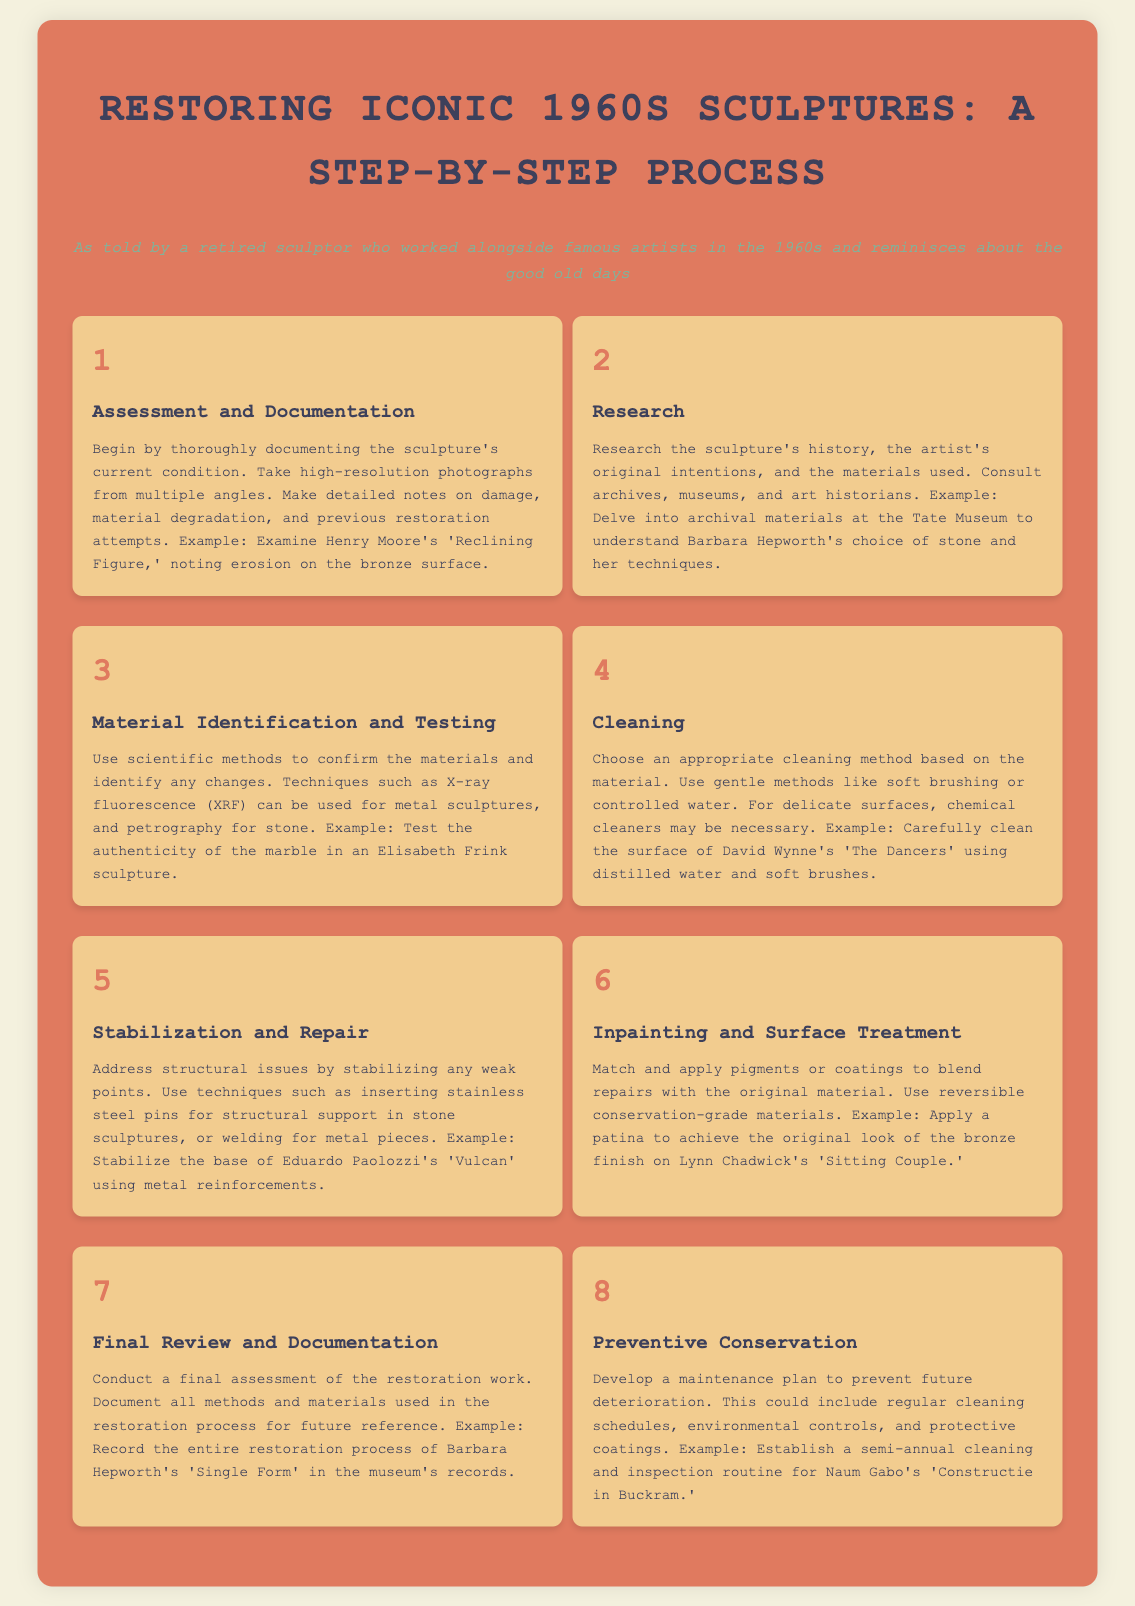What is the first step in the restoration process? The first step in the restoration process, as outlined in the infographic, is Assessment and Documentation.
Answer: Assessment and Documentation Which artist's sculpture is mentioned in the cleaning step? The cleaning step references David Wynne's 'The Dancers.'
Answer: David Wynne's 'The Dancers' How many steps are there in the restoration process? The infographic lists a total of eight steps in the restoration process.
Answer: Eight What technique is suggested for structural support in stone sculptures? The document suggests using stainless steel pins for structural support in stone sculptures.
Answer: Stainless steel pins What is the last step mentioned in the infographic? The last step in the restoration process is Preventive Conservation.
Answer: Preventive Conservation Which sculpture is referenced when discussing inpainting? Lynn Chadwick's 'Sitting Couple' is referenced in the inpainting step.
Answer: Lynn Chadwick's 'Sitting Couple' What method is used for metal sculptures in material testing? The method used for metal sculptures in material testing is X-ray fluorescence (XRF).
Answer: X-ray fluorescence (XRF) What should be documented during the final review? During the final review, all methods and materials used in the restoration process should be documented.
Answer: All methods and materials used in the restoration process 